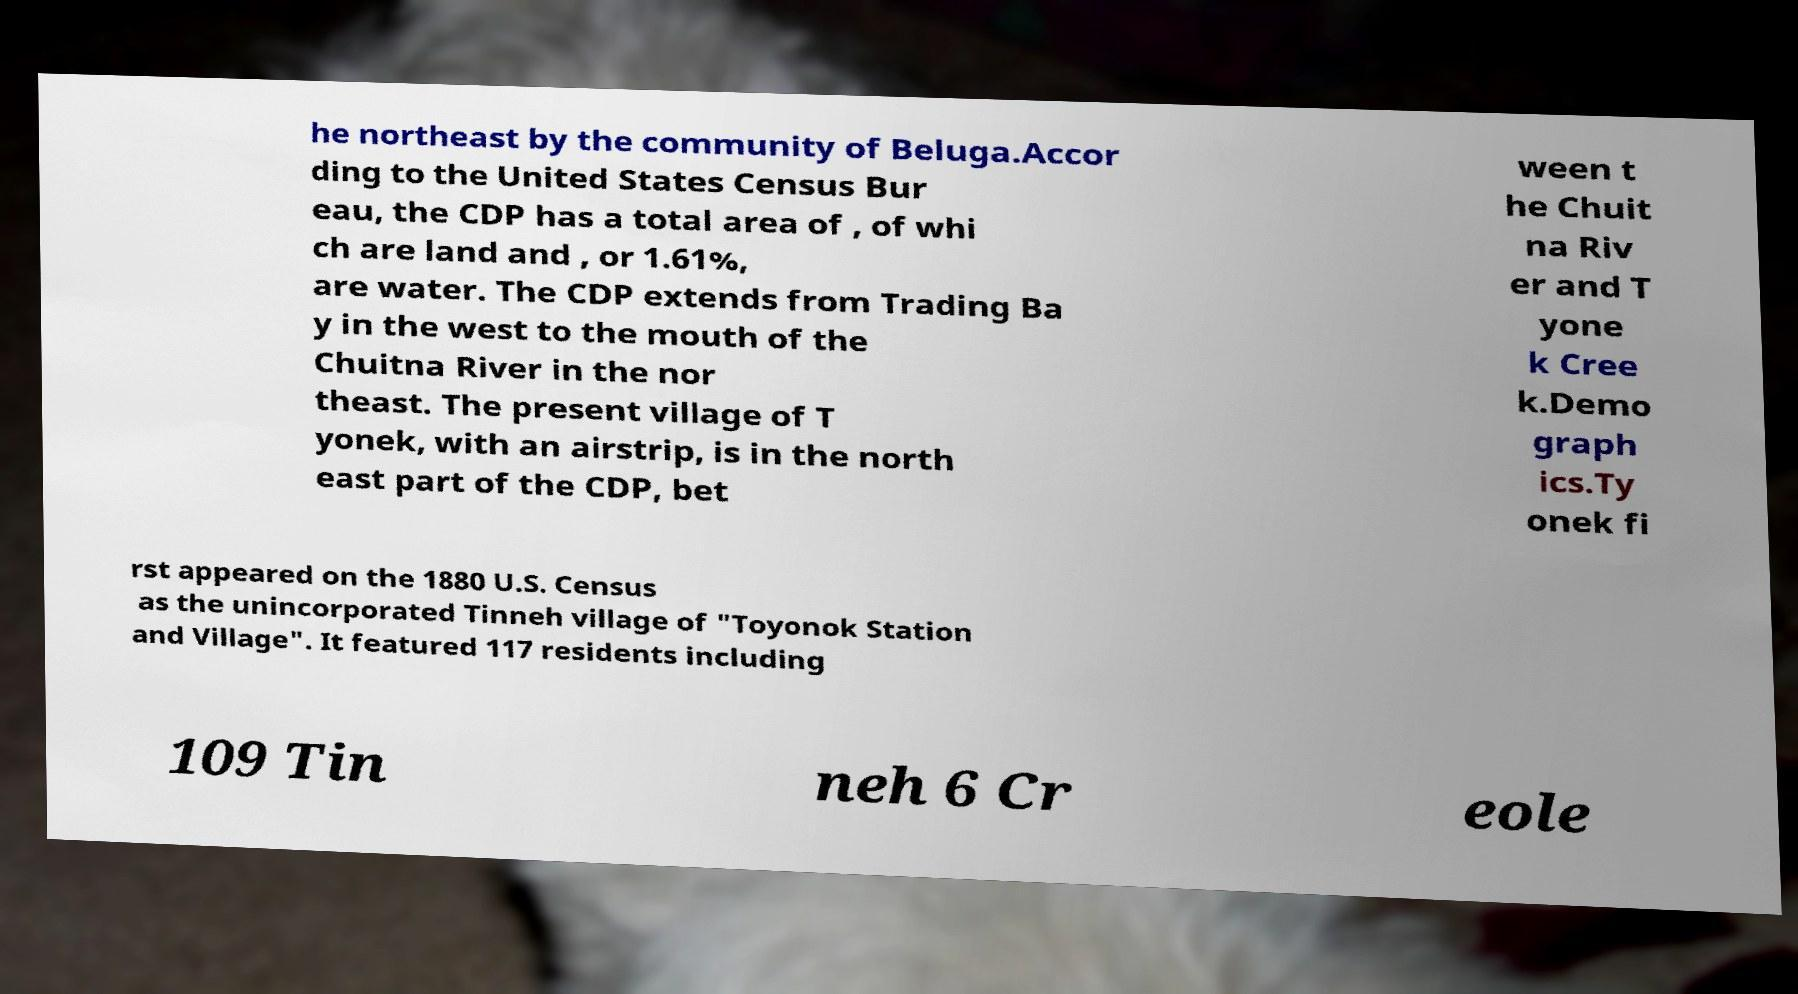Please identify and transcribe the text found in this image. he northeast by the community of Beluga.Accor ding to the United States Census Bur eau, the CDP has a total area of , of whi ch are land and , or 1.61%, are water. The CDP extends from Trading Ba y in the west to the mouth of the Chuitna River in the nor theast. The present village of T yonek, with an airstrip, is in the north east part of the CDP, bet ween t he Chuit na Riv er and T yone k Cree k.Demo graph ics.Ty onek fi rst appeared on the 1880 U.S. Census as the unincorporated Tinneh village of "Toyonok Station and Village". It featured 117 residents including 109 Tin neh 6 Cr eole 